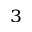<formula> <loc_0><loc_0><loc_500><loc_500>_ { 3 }</formula> 